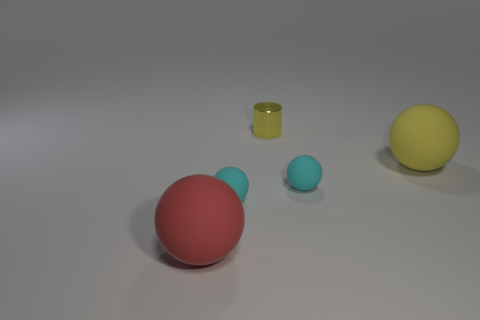There is a cyan ball that is to the right of the tiny metallic thing; are there any tiny cylinders to the right of it?
Ensure brevity in your answer.  No. What number of things are either yellow things on the left side of the big yellow matte thing or yellow objects behind the yellow sphere?
Your answer should be compact. 1. How many things are big yellow balls or big spheres right of the red rubber ball?
Give a very brief answer. 1. What size is the metal object that is behind the large rubber object on the left side of the big ball behind the large red rubber ball?
Offer a terse response. Small. There is another thing that is the same size as the red rubber thing; what is it made of?
Keep it short and to the point. Rubber. Is there a blue shiny cylinder of the same size as the shiny thing?
Keep it short and to the point. No. There is a cyan sphere that is left of the yellow metallic object; does it have the same size as the red ball?
Provide a succinct answer. No. What shape is the thing that is both in front of the big yellow ball and to the right of the yellow metallic cylinder?
Provide a succinct answer. Sphere. Is the number of cyan matte spheres that are to the right of the tiny yellow shiny thing greater than the number of tiny shiny cylinders?
Offer a terse response. No. There is a yellow sphere that is made of the same material as the red object; what is its size?
Make the answer very short. Large. 